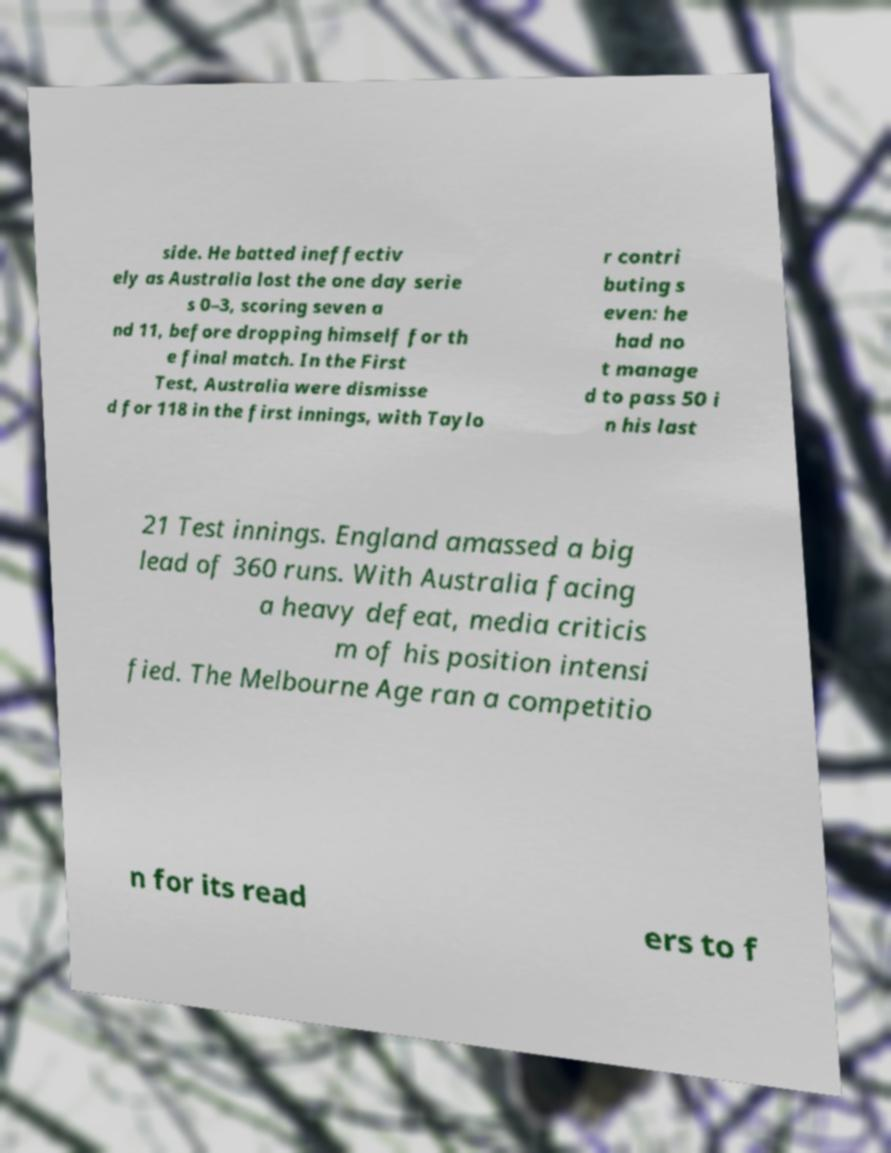For documentation purposes, I need the text within this image transcribed. Could you provide that? side. He batted ineffectiv ely as Australia lost the one day serie s 0–3, scoring seven a nd 11, before dropping himself for th e final match. In the First Test, Australia were dismisse d for 118 in the first innings, with Taylo r contri buting s even: he had no t manage d to pass 50 i n his last 21 Test innings. England amassed a big lead of 360 runs. With Australia facing a heavy defeat, media criticis m of his position intensi fied. The Melbourne Age ran a competitio n for its read ers to f 